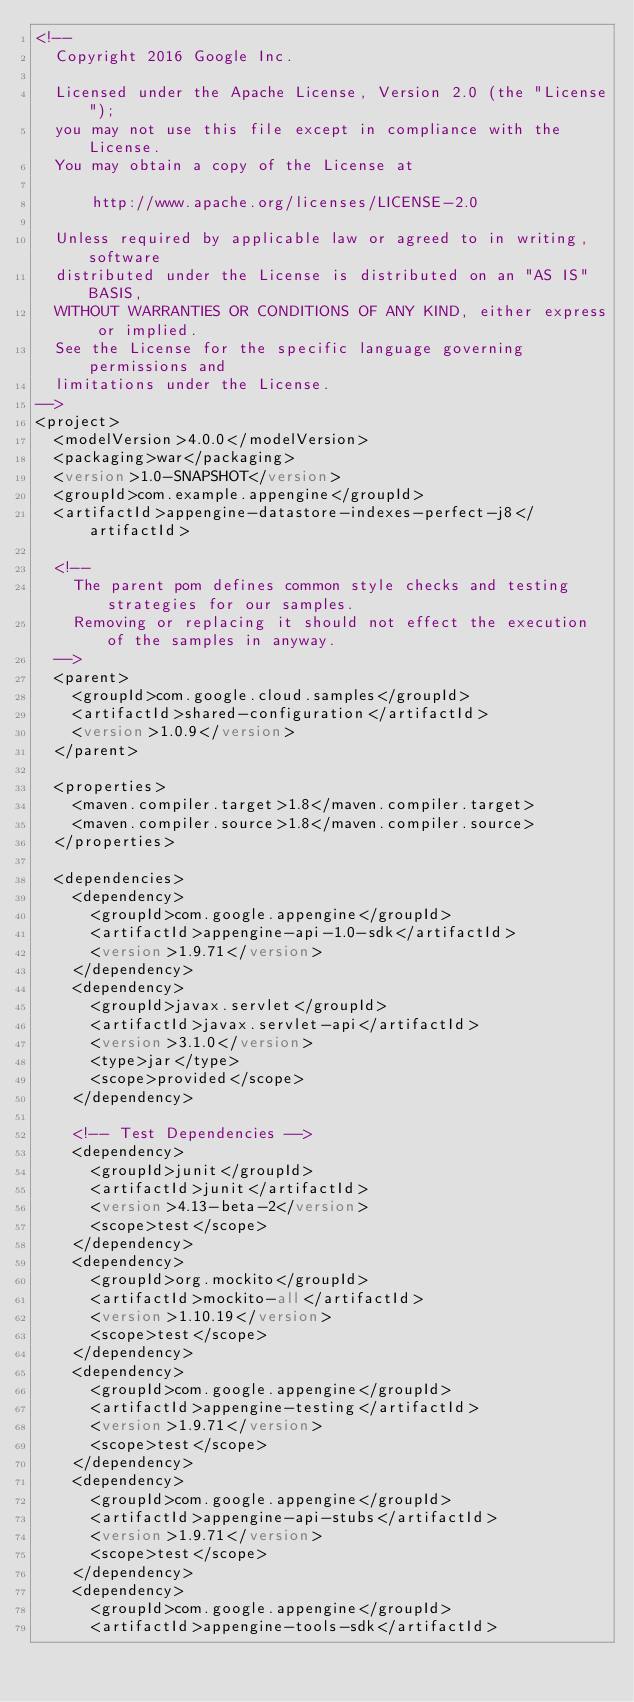<code> <loc_0><loc_0><loc_500><loc_500><_XML_><!--
  Copyright 2016 Google Inc.

  Licensed under the Apache License, Version 2.0 (the "License");
  you may not use this file except in compliance with the License.
  You may obtain a copy of the License at

      http://www.apache.org/licenses/LICENSE-2.0

  Unless required by applicable law or agreed to in writing, software
  distributed under the License is distributed on an "AS IS" BASIS,
  WITHOUT WARRANTIES OR CONDITIONS OF ANY KIND, either express or implied.
  See the License for the specific language governing permissions and
  limitations under the License.
-->
<project>
  <modelVersion>4.0.0</modelVersion>
  <packaging>war</packaging>
  <version>1.0-SNAPSHOT</version>
  <groupId>com.example.appengine</groupId>
  <artifactId>appengine-datastore-indexes-perfect-j8</artifactId>

  <!--
    The parent pom defines common style checks and testing strategies for our samples.
    Removing or replacing it should not effect the execution of the samples in anyway.
  -->
  <parent>
    <groupId>com.google.cloud.samples</groupId>
    <artifactId>shared-configuration</artifactId>
    <version>1.0.9</version>
  </parent>

  <properties>
    <maven.compiler.target>1.8</maven.compiler.target>
    <maven.compiler.source>1.8</maven.compiler.source>
  </properties>

  <dependencies>
    <dependency>
      <groupId>com.google.appengine</groupId>
      <artifactId>appengine-api-1.0-sdk</artifactId>
      <version>1.9.71</version>
    </dependency>
    <dependency>
      <groupId>javax.servlet</groupId>
      <artifactId>javax.servlet-api</artifactId>
      <version>3.1.0</version>
      <type>jar</type>
      <scope>provided</scope>
    </dependency>

    <!-- Test Dependencies -->
    <dependency>
      <groupId>junit</groupId>
      <artifactId>junit</artifactId>
      <version>4.13-beta-2</version>
      <scope>test</scope>
    </dependency>
    <dependency>
      <groupId>org.mockito</groupId>
      <artifactId>mockito-all</artifactId>
      <version>1.10.19</version>
      <scope>test</scope>
    </dependency>
    <dependency>
      <groupId>com.google.appengine</groupId>
      <artifactId>appengine-testing</artifactId>
      <version>1.9.71</version>
      <scope>test</scope>
    </dependency>
    <dependency>
      <groupId>com.google.appengine</groupId>
      <artifactId>appengine-api-stubs</artifactId>
      <version>1.9.71</version>
      <scope>test</scope>
    </dependency>
    <dependency>
      <groupId>com.google.appengine</groupId>
      <artifactId>appengine-tools-sdk</artifactId></code> 